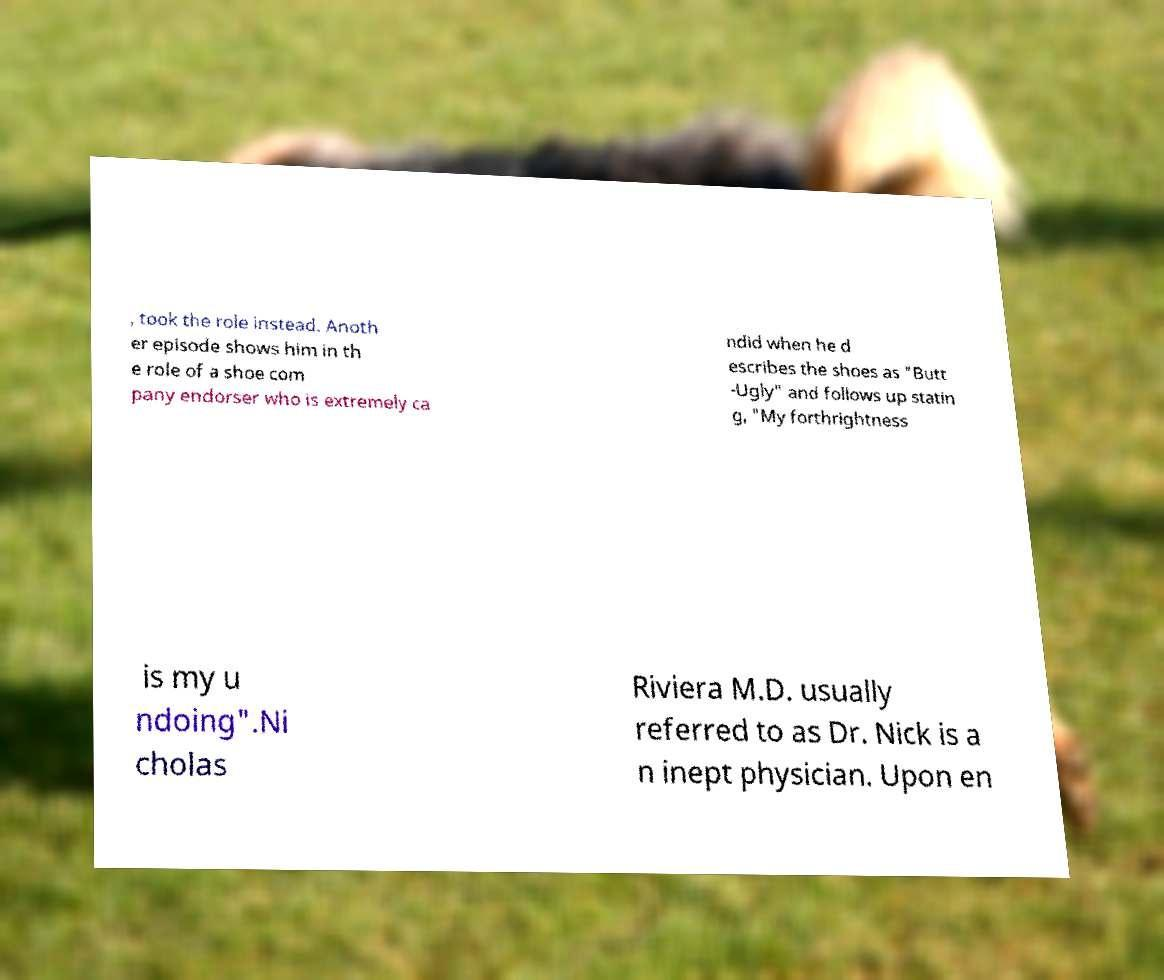I need the written content from this picture converted into text. Can you do that? , took the role instead. Anoth er episode shows him in th e role of a shoe com pany endorser who is extremely ca ndid when he d escribes the shoes as "Butt -Ugly" and follows up statin g, "My forthrightness is my u ndoing".Ni cholas Riviera M.D. usually referred to as Dr. Nick is a n inept physician. Upon en 